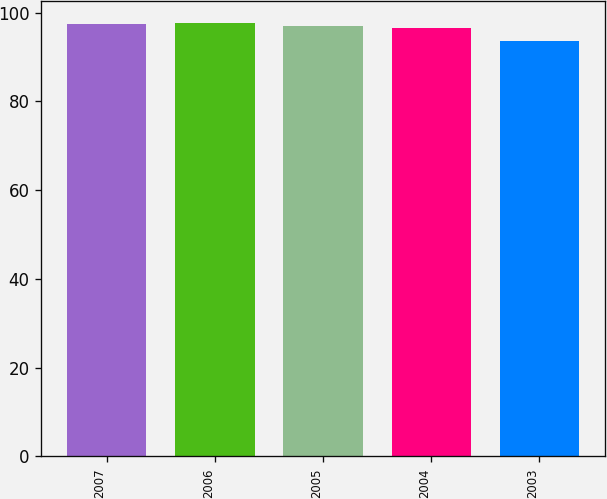Convert chart. <chart><loc_0><loc_0><loc_500><loc_500><bar_chart><fcel>2007<fcel>2006<fcel>2005<fcel>2004<fcel>2003<nl><fcel>97.38<fcel>97.76<fcel>97<fcel>96.5<fcel>93.6<nl></chart> 